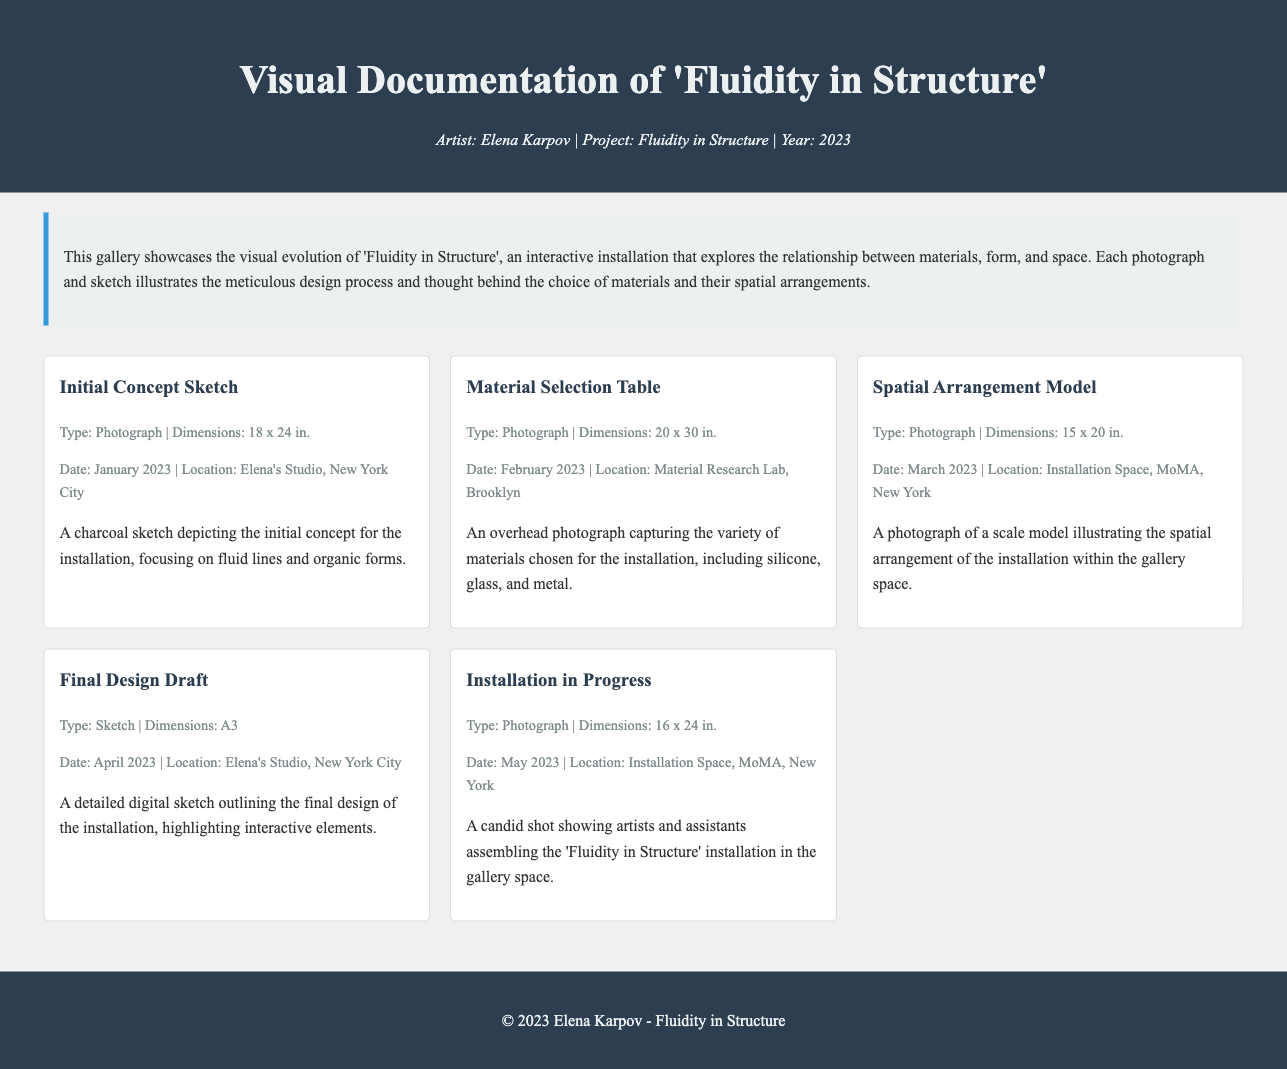What is the title of the installation? The title of the installation is prominently stated in the header section of the document.
Answer: Fluidity in Structure Who is the artist of the project? The artist's name is mentioned right after the title in the header section.
Answer: Elena Karpov What is the date of the Initial Concept Sketch? The date is listed under the details of the corresponding item in the gallery.
Answer: January 2023 How many photographs are included in the gallery? The gallery contains a total of five items, and all are photographs or sketches.
Answer: 5 What material is highlighted in the Material Selection Table? The item description lists specifics about the materials chosen for the installation.
Answer: Silicone, glass, and metal What size is the Final Design Draft? The dimensions are specified right under the item title in the gallery.
Answer: A3 In which location was the Installation in Progress photograph taken? The location is provided under the details of the corresponding item in the gallery.
Answer: Installation Space, MoMA, New York What month was the Spatial Arrangement Model created? The date mentioned under that item indicates the month of creation.
Answer: March How does the installation relate to space? The description states that the installation explores the relationship between materials, form, and space.
Answer: Relationship between materials, form, and space 